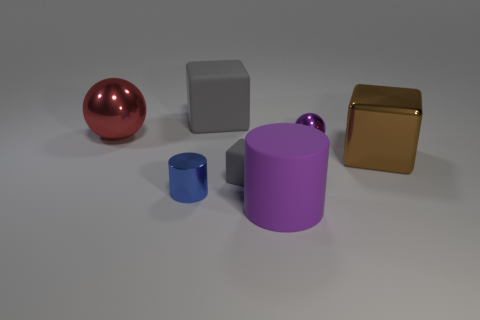The metal cylinder is what color?
Your response must be concise. Blue. Does the metallic cylinder have the same color as the big cube that is right of the purple cylinder?
Your answer should be compact. No. Is there a brown cylinder of the same size as the purple metal sphere?
Offer a very short reply. No. What size is the metal ball that is the same color as the big matte cylinder?
Make the answer very short. Small. There is a ball that is on the left side of the big gray matte thing; what is its material?
Provide a succinct answer. Metal. Are there an equal number of gray objects that are in front of the brown cube and small cubes behind the big gray block?
Offer a very short reply. No. Is the size of the metallic sphere right of the small metallic cylinder the same as the brown shiny object right of the big gray rubber cube?
Make the answer very short. No. What number of tiny metal spheres are the same color as the matte cylinder?
Give a very brief answer. 1. There is a big thing that is the same color as the small matte object; what is it made of?
Offer a very short reply. Rubber. Is the number of big brown shiny blocks that are left of the small blue shiny thing greater than the number of shiny balls?
Give a very brief answer. No. 